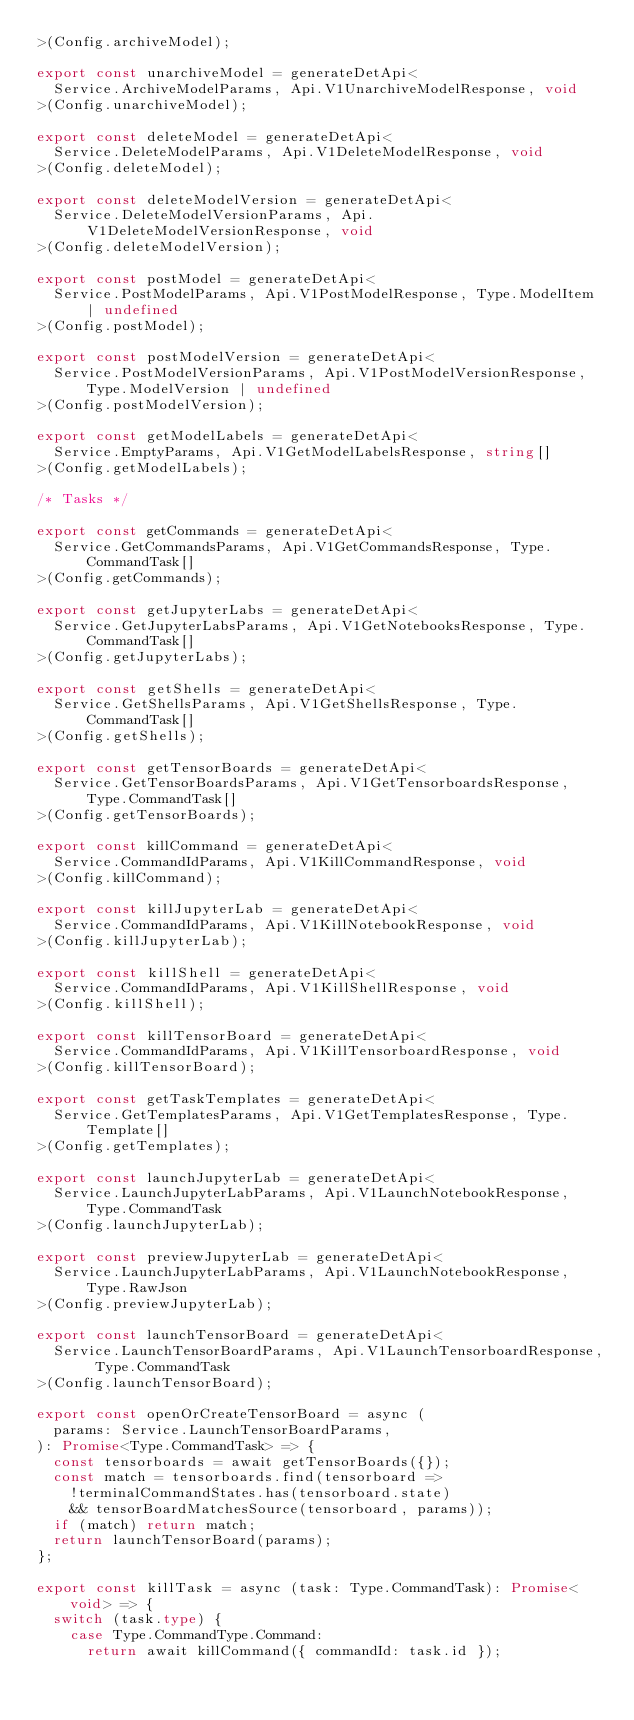<code> <loc_0><loc_0><loc_500><loc_500><_TypeScript_>>(Config.archiveModel);

export const unarchiveModel = generateDetApi<
  Service.ArchiveModelParams, Api.V1UnarchiveModelResponse, void
>(Config.unarchiveModel);

export const deleteModel = generateDetApi<
  Service.DeleteModelParams, Api.V1DeleteModelResponse, void
>(Config.deleteModel);

export const deleteModelVersion = generateDetApi<
  Service.DeleteModelVersionParams, Api.V1DeleteModelVersionResponse, void
>(Config.deleteModelVersion);

export const postModel = generateDetApi<
  Service.PostModelParams, Api.V1PostModelResponse, Type.ModelItem | undefined
>(Config.postModel);

export const postModelVersion = generateDetApi<
  Service.PostModelVersionParams, Api.V1PostModelVersionResponse, Type.ModelVersion | undefined
>(Config.postModelVersion);

export const getModelLabels = generateDetApi<
  Service.EmptyParams, Api.V1GetModelLabelsResponse, string[]
>(Config.getModelLabels);

/* Tasks */

export const getCommands = generateDetApi<
  Service.GetCommandsParams, Api.V1GetCommandsResponse, Type.CommandTask[]
>(Config.getCommands);

export const getJupyterLabs = generateDetApi<
  Service.GetJupyterLabsParams, Api.V1GetNotebooksResponse, Type.CommandTask[]
>(Config.getJupyterLabs);

export const getShells = generateDetApi<
  Service.GetShellsParams, Api.V1GetShellsResponse, Type.CommandTask[]
>(Config.getShells);

export const getTensorBoards = generateDetApi<
  Service.GetTensorBoardsParams, Api.V1GetTensorboardsResponse, Type.CommandTask[]
>(Config.getTensorBoards);

export const killCommand = generateDetApi<
  Service.CommandIdParams, Api.V1KillCommandResponse, void
>(Config.killCommand);

export const killJupyterLab = generateDetApi<
  Service.CommandIdParams, Api.V1KillNotebookResponse, void
>(Config.killJupyterLab);

export const killShell = generateDetApi<
  Service.CommandIdParams, Api.V1KillShellResponse, void
>(Config.killShell);

export const killTensorBoard = generateDetApi<
  Service.CommandIdParams, Api.V1KillTensorboardResponse, void
>(Config.killTensorBoard);

export const getTaskTemplates = generateDetApi<
  Service.GetTemplatesParams, Api.V1GetTemplatesResponse, Type.Template[]
>(Config.getTemplates);

export const launchJupyterLab = generateDetApi<
  Service.LaunchJupyterLabParams, Api.V1LaunchNotebookResponse, Type.CommandTask
>(Config.launchJupyterLab);

export const previewJupyterLab = generateDetApi<
  Service.LaunchJupyterLabParams, Api.V1LaunchNotebookResponse, Type.RawJson
>(Config.previewJupyterLab);

export const launchTensorBoard = generateDetApi<
  Service.LaunchTensorBoardParams, Api.V1LaunchTensorboardResponse, Type.CommandTask
>(Config.launchTensorBoard);

export const openOrCreateTensorBoard = async (
  params: Service.LaunchTensorBoardParams,
): Promise<Type.CommandTask> => {
  const tensorboards = await getTensorBoards({});
  const match = tensorboards.find(tensorboard =>
    !terminalCommandStates.has(tensorboard.state)
    && tensorBoardMatchesSource(tensorboard, params));
  if (match) return match;
  return launchTensorBoard(params);
};

export const killTask = async (task: Type.CommandTask): Promise<void> => {
  switch (task.type) {
    case Type.CommandType.Command:
      return await killCommand({ commandId: task.id });</code> 